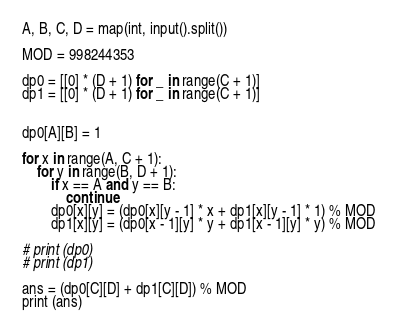<code> <loc_0><loc_0><loc_500><loc_500><_Python_>A, B, C, D = map(int, input().split())

MOD = 998244353

dp0 = [[0] * (D + 1) for _ in range(C + 1)]
dp1 = [[0] * (D + 1) for _ in range(C + 1)]


dp0[A][B] = 1

for x in range(A, C + 1):
    for y in range(B, D + 1):
        if x == A and y == B:
            continue
        dp0[x][y] = (dp0[x][y - 1] * x + dp1[x][y - 1] * 1) % MOD
        dp1[x][y] = (dp0[x - 1][y] * y + dp1[x - 1][y] * y) % MOD

# print (dp0)
# print (dp1)        

ans = (dp0[C][D] + dp1[C][D]) % MOD
print (ans)</code> 